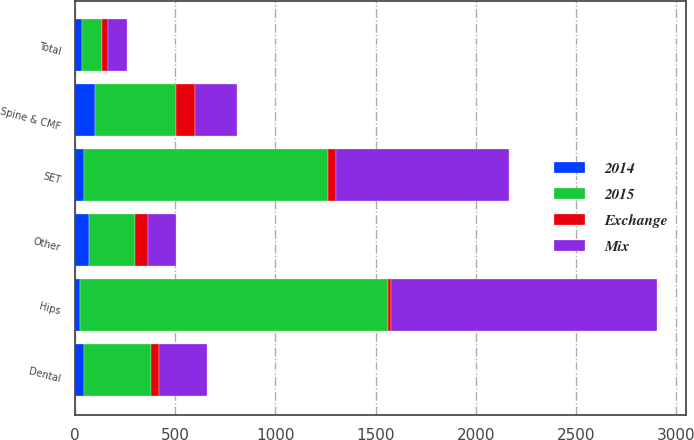Convert chart to OTSL. <chart><loc_0><loc_0><loc_500><loc_500><stacked_bar_chart><ecel><fcel>Hips<fcel>SET<fcel>Dental<fcel>Spine & CMF<fcel>Other<fcel>Total<nl><fcel>2015<fcel>1537.2<fcel>1214.9<fcel>335.7<fcel>404.4<fcel>228.8<fcel>98.2<nl><fcel>Mix<fcel>1326.4<fcel>863.2<fcel>242.8<fcel>207.2<fcel>138.5<fcel>98.2<nl><fcel>Exchange<fcel>15.9<fcel>40.7<fcel>38.2<fcel>95.2<fcel>65.3<fcel>28.3<nl><fcel>2014<fcel>26.1<fcel>46.8<fcel>45<fcel>101.2<fcel>70.4<fcel>36.7<nl></chart> 